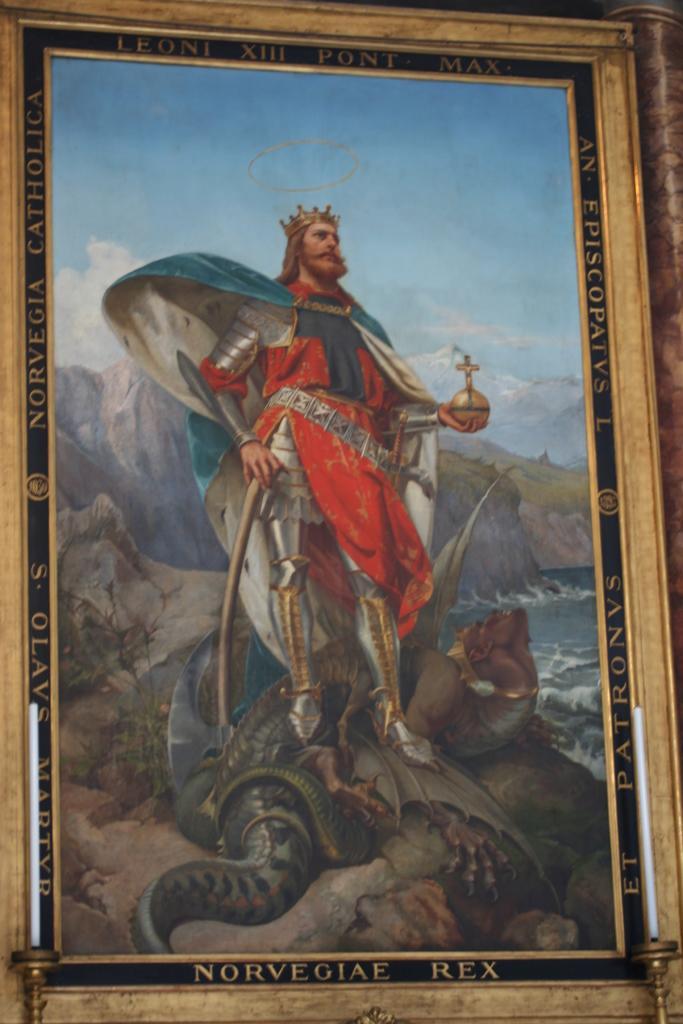In one or two sentences, can you explain what this image depicts? A picture with frame. In-front of this frame there are candles. This man is holding objects. Here we can see water. Sky is cloudy. 